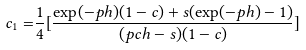Convert formula to latex. <formula><loc_0><loc_0><loc_500><loc_500>c _ { 1 } = & \frac { 1 } { 4 } [ \frac { \exp ( - p h ) ( 1 - c ) + s ( \exp ( - p h ) - 1 ) } { ( p c h - s ) ( 1 - c ) } ]</formula> 